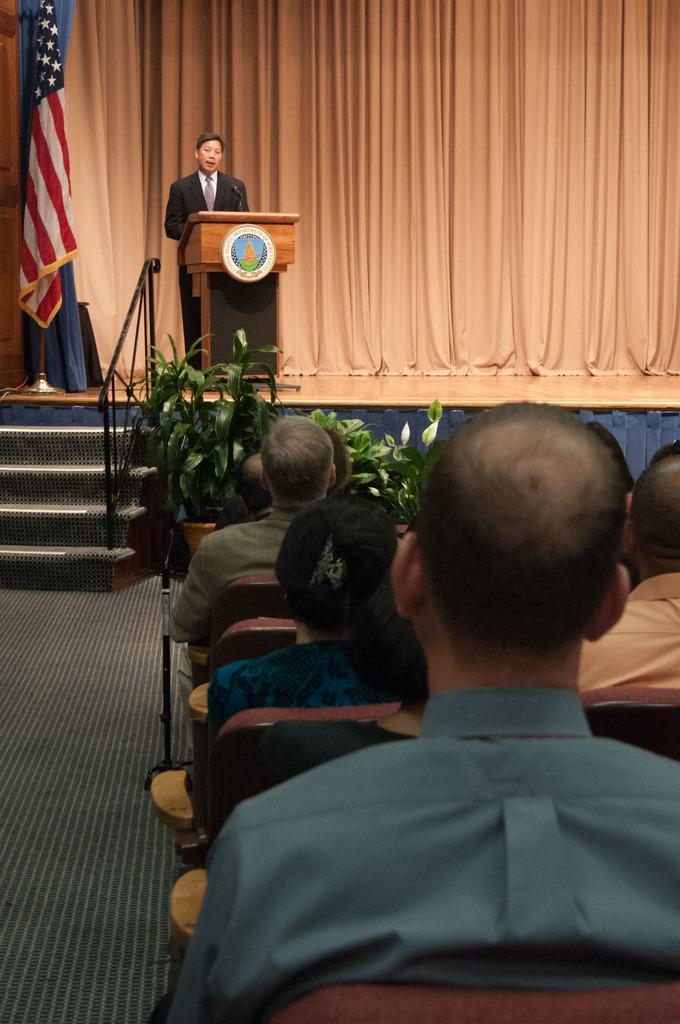In one or two sentences, can you explain what this image depicts? In this image we can see people sitting on the chairs. Here we can see floor, plants, steps, railing, flag, and a podium. Here we can see a man is standing in front of a mike. In the background we can see a curtain. 